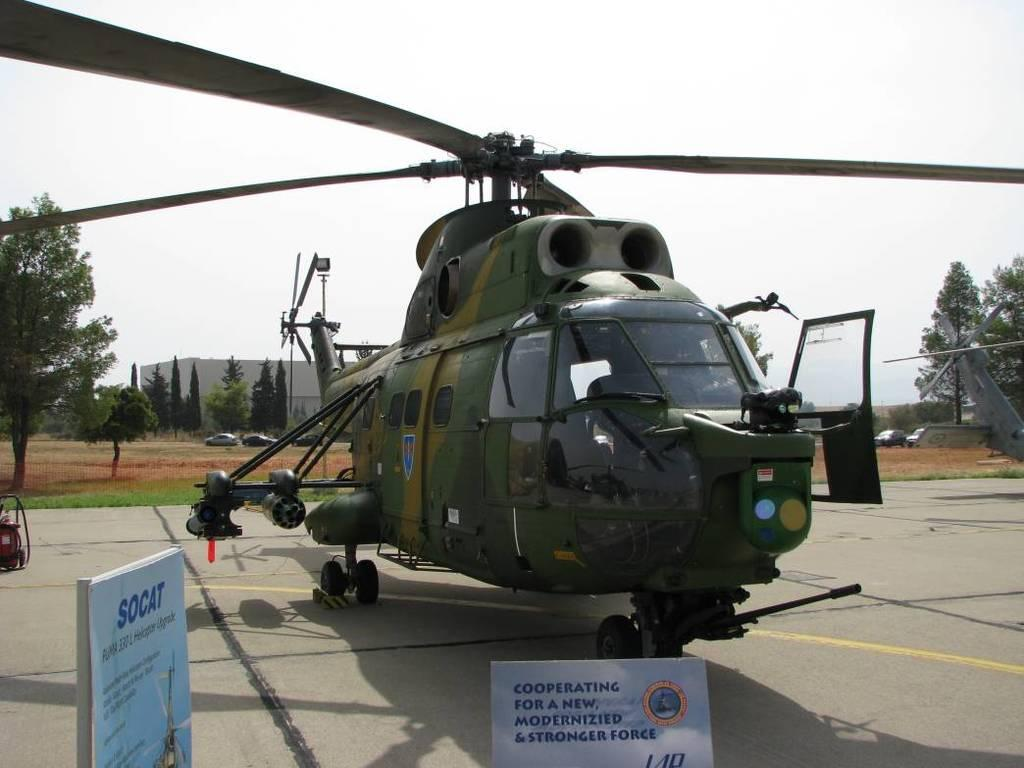<image>
Present a compact description of the photo's key features. a army helicopter on the ground with sings around, one says SOCAT on it but it's blurry. 